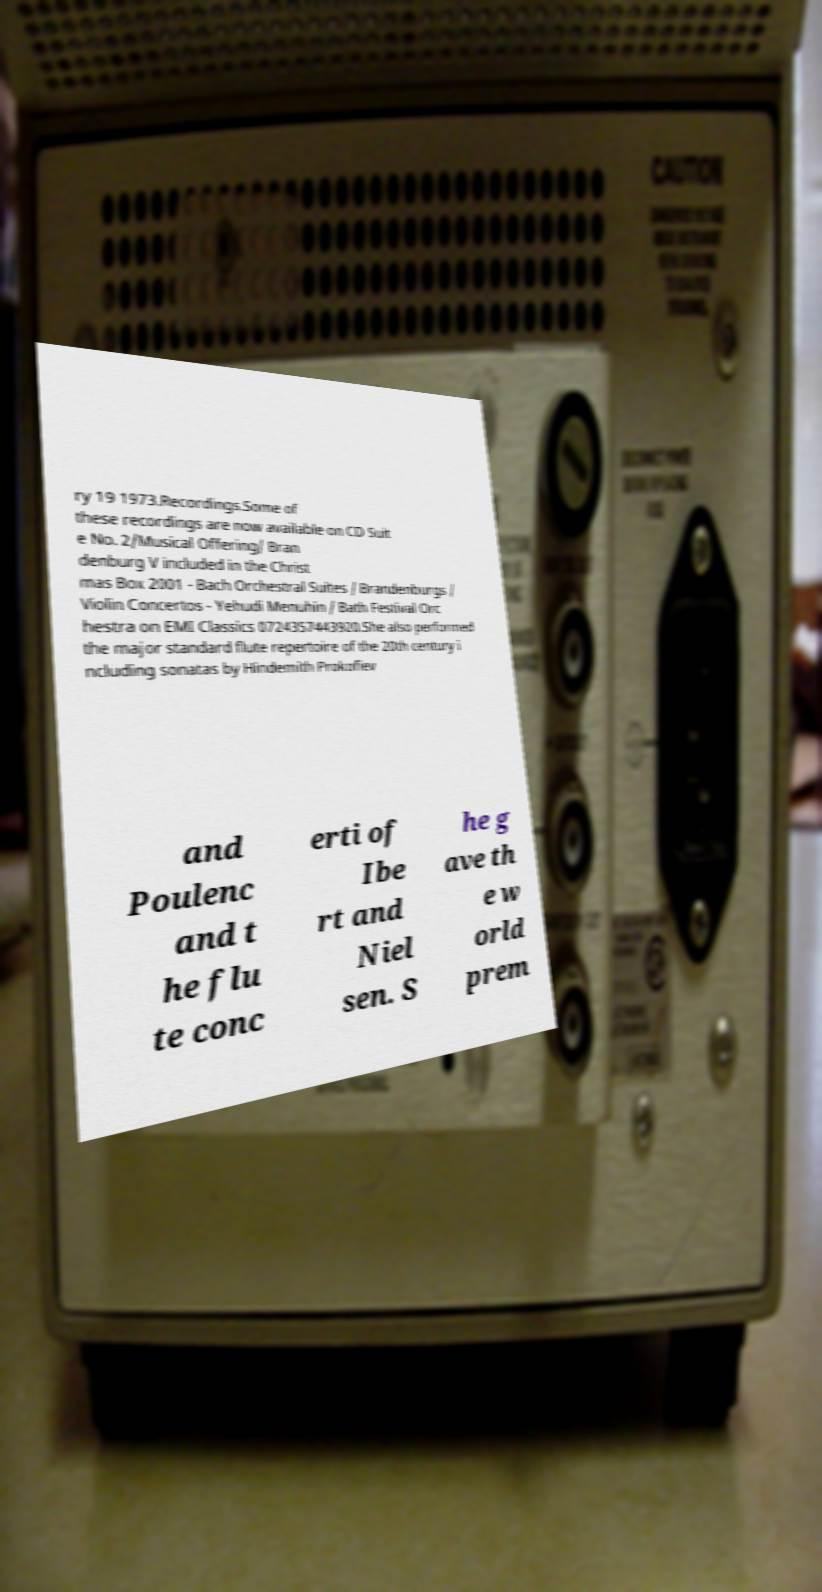Could you assist in decoding the text presented in this image and type it out clearly? ry 19 1973.Recordings.Some of these recordings are now available on CD Suit e No. 2/Musical Offering/ Bran denburg V included in the Christ mas Box 2001 - Bach Orchestral Suites / Brandenburgs / Violin Concertos - Yehudi Menuhin / Bath Festival Orc hestra on EMI Classics 0724357443920.She also performed the major standard flute repertoire of the 20th century i ncluding sonatas by Hindemith Prokofiev and Poulenc and t he flu te conc erti of Ibe rt and Niel sen. S he g ave th e w orld prem 